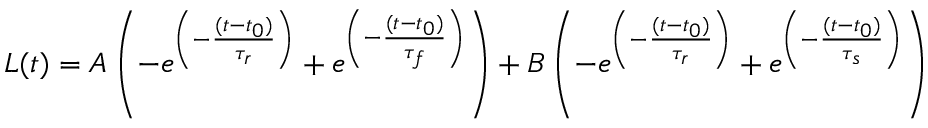<formula> <loc_0><loc_0><loc_500><loc_500>L ( t ) = A \left ( - e ^ { \left ( - \frac { ( t - t _ { 0 } ) } { \tau _ { r } } \right ) } + e ^ { \left ( - \frac { ( t - t _ { 0 } ) } { \tau _ { f } } \right ) } \right ) + B \left ( - e ^ { \left ( - \frac { ( t - t _ { 0 } ) } { \tau _ { r } } \right ) } + e ^ { \left ( - \frac { ( t - t _ { 0 } ) } { \tau _ { s } } \right ) } \right )</formula> 